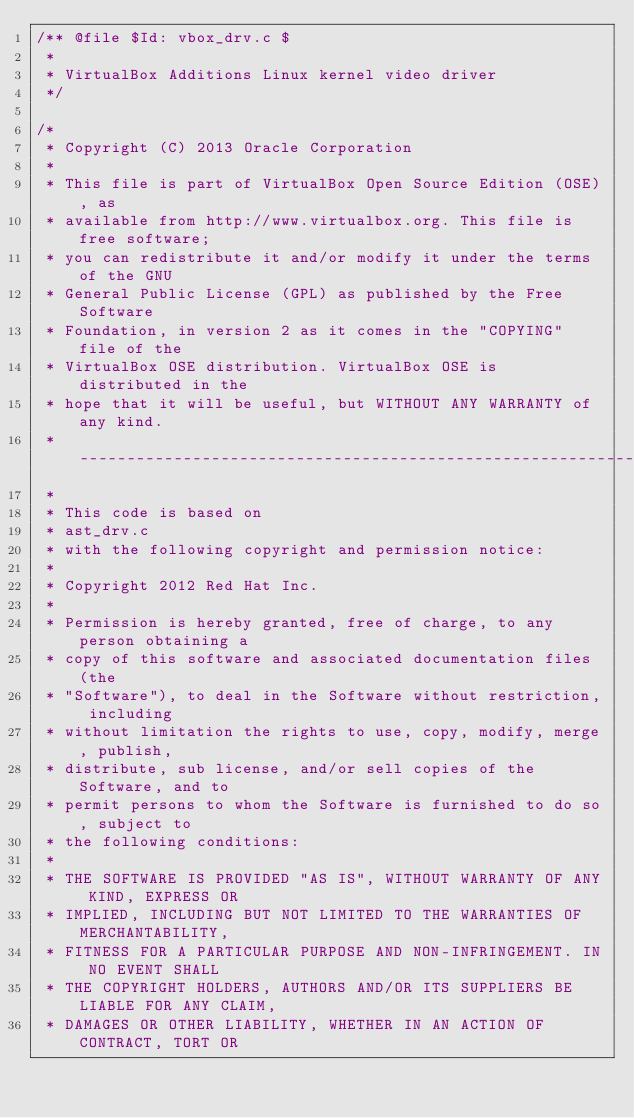Convert code to text. <code><loc_0><loc_0><loc_500><loc_500><_C_>/** @file $Id: vbox_drv.c $
 *
 * VirtualBox Additions Linux kernel video driver
 */

/*
 * Copyright (C) 2013 Oracle Corporation
 *
 * This file is part of VirtualBox Open Source Edition (OSE), as
 * available from http://www.virtualbox.org. This file is free software;
 * you can redistribute it and/or modify it under the terms of the GNU
 * General Public License (GPL) as published by the Free Software
 * Foundation, in version 2 as it comes in the "COPYING" file of the
 * VirtualBox OSE distribution. VirtualBox OSE is distributed in the
 * hope that it will be useful, but WITHOUT ANY WARRANTY of any kind.
 * --------------------------------------------------------------------
 *
 * This code is based on
 * ast_drv.c
 * with the following copyright and permission notice:
 *
 * Copyright 2012 Red Hat Inc.
 *
 * Permission is hereby granted, free of charge, to any person obtaining a
 * copy of this software and associated documentation files (the
 * "Software"), to deal in the Software without restriction, including
 * without limitation the rights to use, copy, modify, merge, publish,
 * distribute, sub license, and/or sell copies of the Software, and to
 * permit persons to whom the Software is furnished to do so, subject to
 * the following conditions:
 *
 * THE SOFTWARE IS PROVIDED "AS IS", WITHOUT WARRANTY OF ANY KIND, EXPRESS OR
 * IMPLIED, INCLUDING BUT NOT LIMITED TO THE WARRANTIES OF MERCHANTABILITY,
 * FITNESS FOR A PARTICULAR PURPOSE AND NON-INFRINGEMENT. IN NO EVENT SHALL
 * THE COPYRIGHT HOLDERS, AUTHORS AND/OR ITS SUPPLIERS BE LIABLE FOR ANY CLAIM,
 * DAMAGES OR OTHER LIABILITY, WHETHER IN AN ACTION OF CONTRACT, TORT OR</code> 